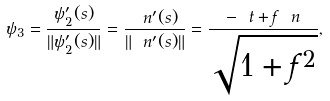Convert formula to latex. <formula><loc_0><loc_0><loc_500><loc_500>\psi _ { 3 } = \frac { \psi ^ { \prime } _ { 2 } ( s ) } { \| \psi ^ { \prime } _ { 2 } ( s ) \| } = \frac { \ n ^ { \prime } ( s ) } { \| \ n ^ { \prime } ( s ) \| } = \frac { - \ t + f \ n } { \sqrt { 1 + f ^ { 2 } } } ,</formula> 